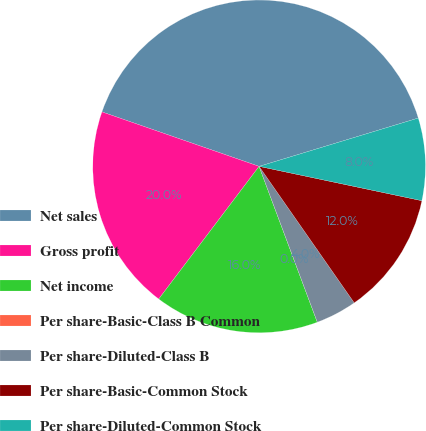<chart> <loc_0><loc_0><loc_500><loc_500><pie_chart><fcel>Net sales<fcel>Gross profit<fcel>Net income<fcel>Per share-Basic-Class B Common<fcel>Per share-Diluted-Class B<fcel>Per share-Basic-Common Stock<fcel>Per share-Diluted-Common Stock<nl><fcel>40.0%<fcel>20.0%<fcel>16.0%<fcel>0.0%<fcel>4.0%<fcel>12.0%<fcel>8.0%<nl></chart> 